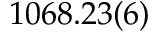Convert formula to latex. <formula><loc_0><loc_0><loc_500><loc_500>1 0 6 8 . 2 3 ( 6 )</formula> 